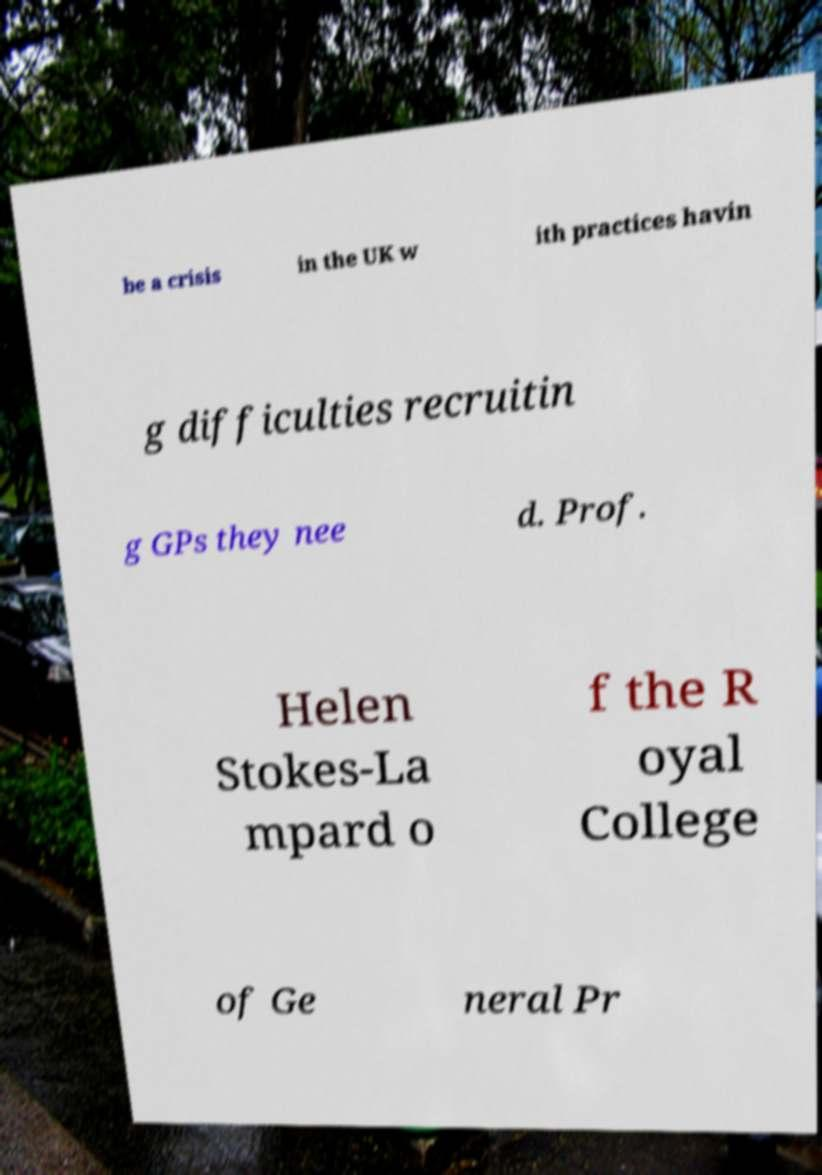I need the written content from this picture converted into text. Can you do that? be a crisis in the UK w ith practices havin g difficulties recruitin g GPs they nee d. Prof. Helen Stokes-La mpard o f the R oyal College of Ge neral Pr 